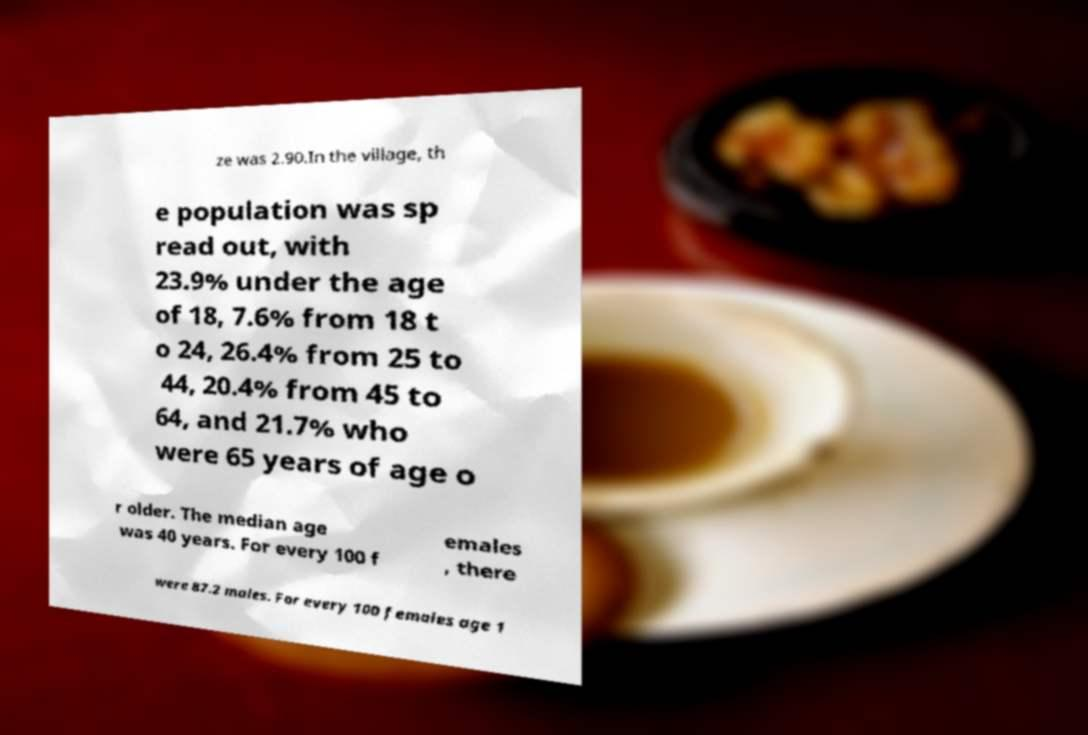Can you read and provide the text displayed in the image?This photo seems to have some interesting text. Can you extract and type it out for me? ze was 2.90.In the village, th e population was sp read out, with 23.9% under the age of 18, 7.6% from 18 t o 24, 26.4% from 25 to 44, 20.4% from 45 to 64, and 21.7% who were 65 years of age o r older. The median age was 40 years. For every 100 f emales , there were 87.2 males. For every 100 females age 1 